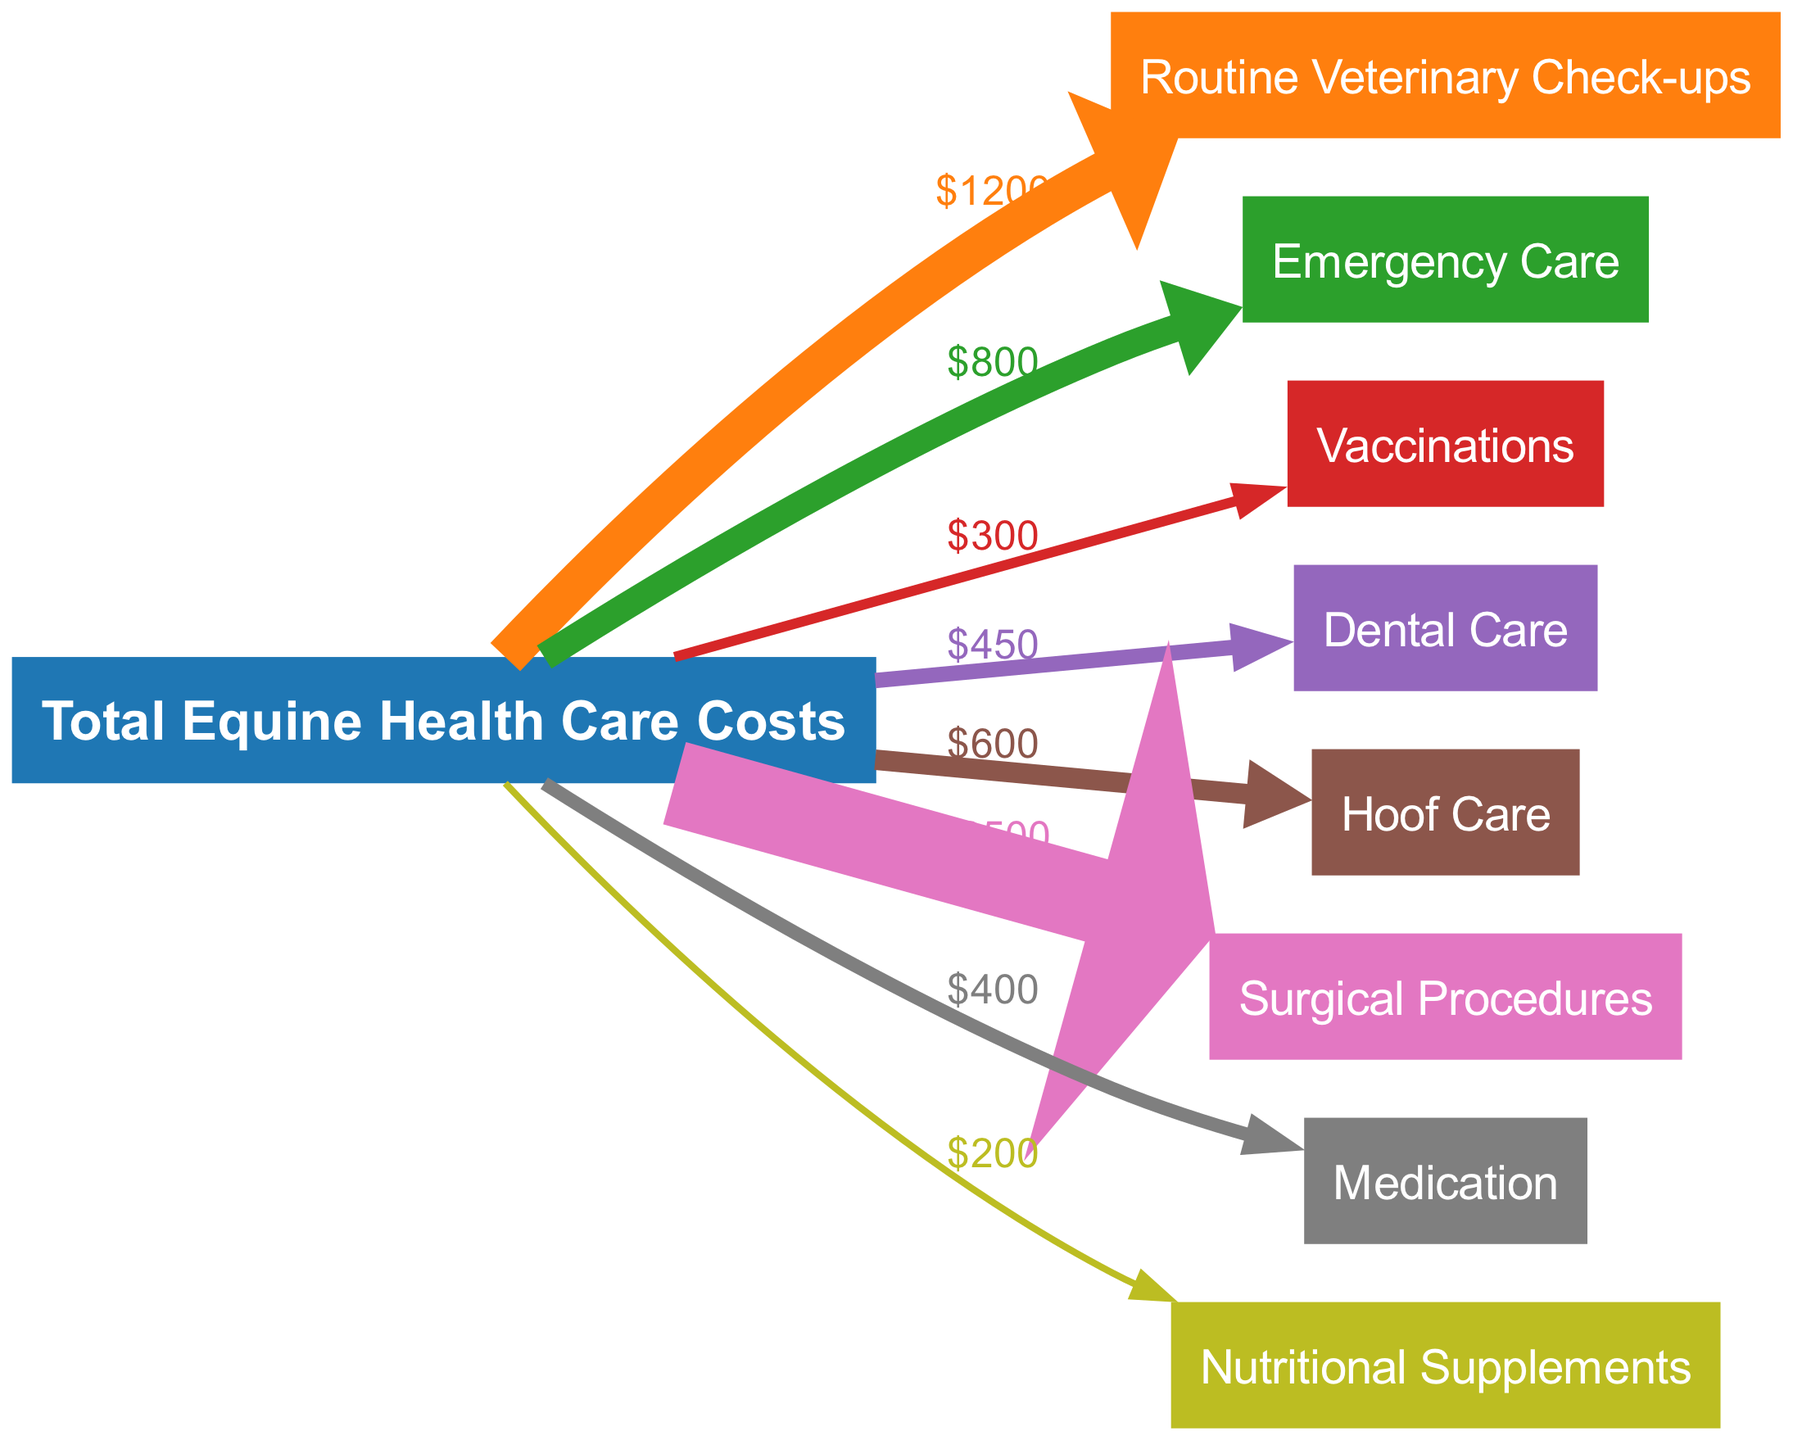What is the total cost of routine veterinary check-ups? The diagram indicates that the link from "Total Equine Health Care Costs" to "Routine Veterinary Check-ups" has a value of $1200. Hence, this is the cost associated with that specific service.
Answer: 1200 Which service has the highest cost in the diagram? By examining the values associated with each service, "Surgical Procedures" shows the highest cost value of $2500, clearly indicating it as the most expensive service.
Answer: Surgical Procedures How many services are listed in the diagram? The diagram features a total of eight services that branch from "Total Equine Health Care Costs." Counting each service node, we find there are eight.
Answer: 8 What is the cost of emergency care? The link from "Total Equine Health Care Costs" to "Emergency Care" shows a value of $800. Thus, this is the specified cost for emergency services.
Answer: 800 What is the combined cost of vaccinations and nutritional supplements? The cost of "Vaccinations" is $300 and "Nutritional Supplements" is $200. Adding these amounts together (300 + 200) results in a total of $500.
Answer: 500 Which service has a cost below $400? Reviewing the costs in the diagram, "Nutritional Supplements" ($200) and "Vaccinations" ($300) both fall below $400, making them the services with lower costs.
Answer: Nutritional Supplements How much does hoof care cost compared to dental care? "Hoof Care" costs $600 while "Dental Care" costs $450. Comparing the two shows that hoof care is $150 more expensive than dental care.
Answer: $150 more expensive What is the value of medication? When looking at the corresponding edge for "Medication," it shows a value of $400, which directly represents the cost for this service.
Answer: 400 